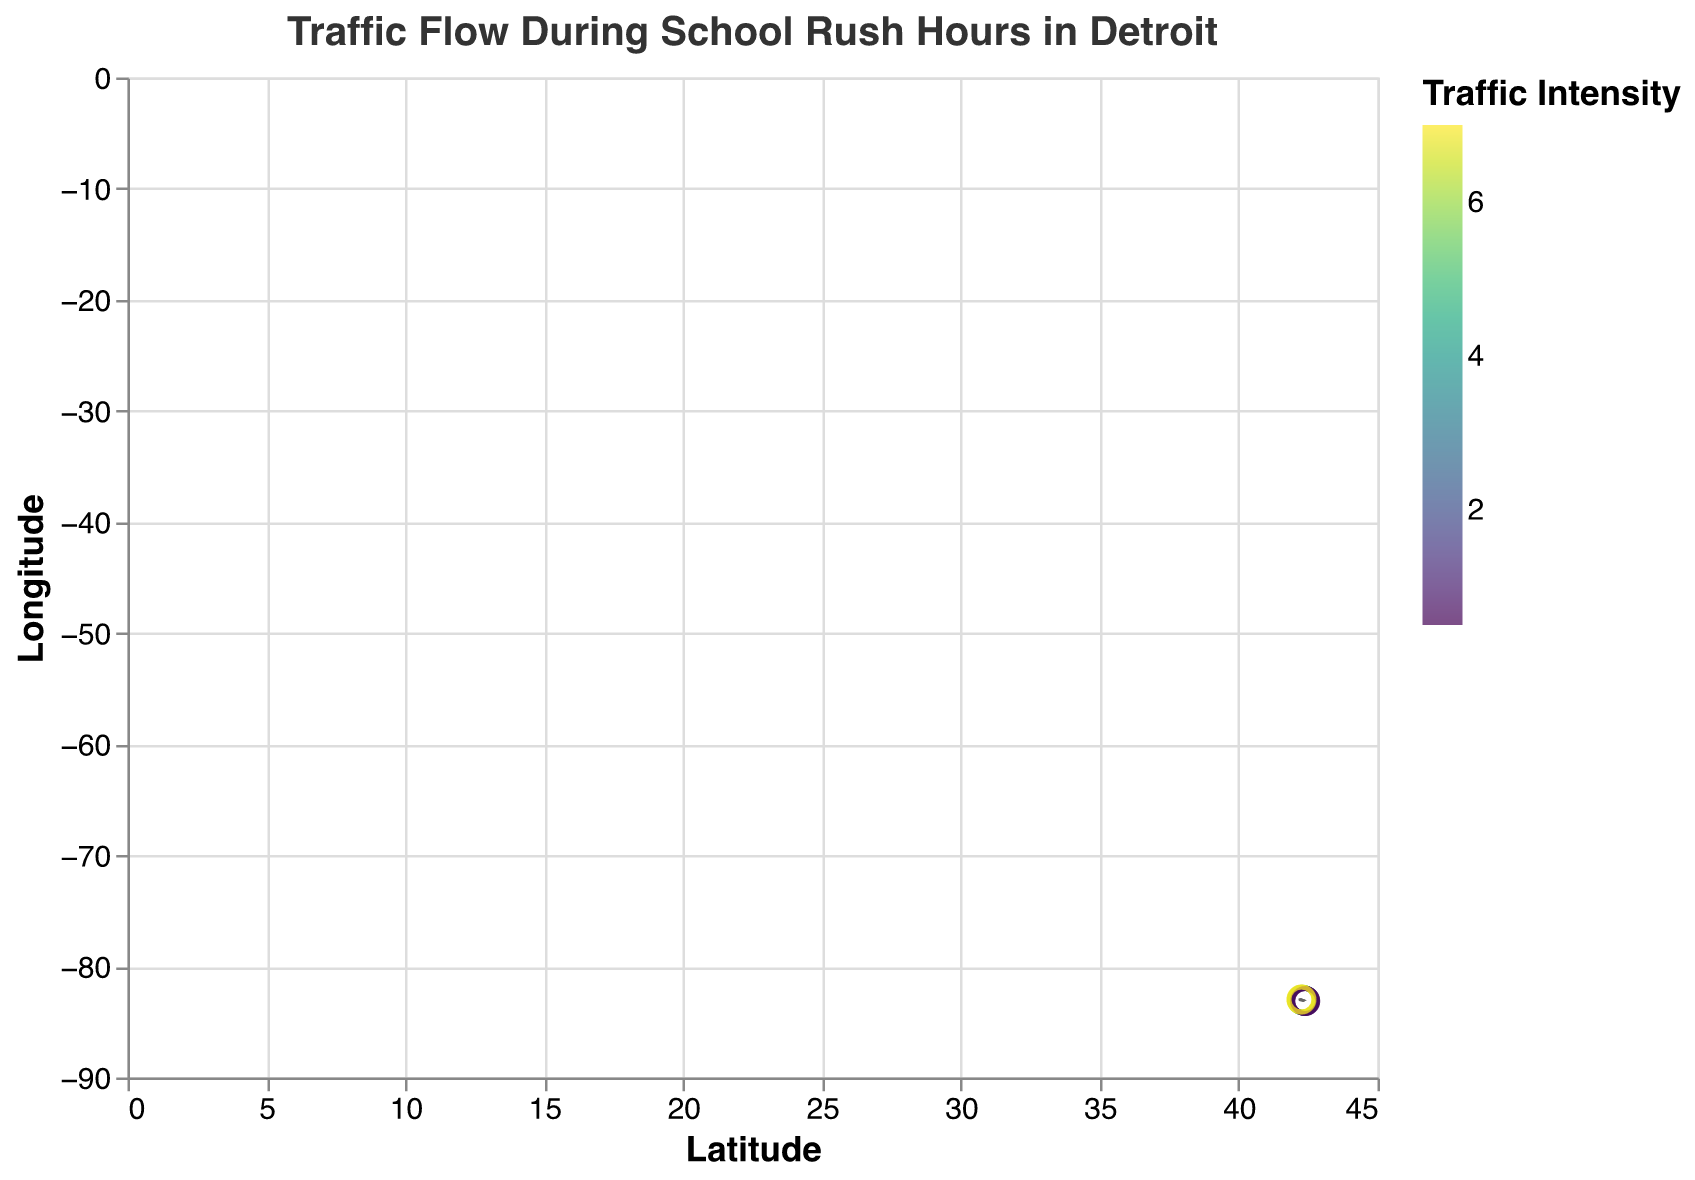What is the title of the figure? The title of the figure is prominently displayed at the top. It reads "Traffic Flow During School Rush Hours in Detroit".
Answer: Traffic Flow During School Rush Hours in Detroit How many data points are represented in the plot? There are a total of 15 points represented in the plot, each with a specific latitude and longitude configuration.
Answer: 15 Which point has the highest traffic intensity and what is its value? The color intensity of the points indicates traffic flow. The point at (42.26, -82.98) has the deepest color, corresponding to the highest traffic intensity value of 7.0.
Answer: 7.0 Which two points have the lowest traffic intensity? By observing the color scale, the points at (42.39, -83.11) and (42.40, -83.12) have much lighter colors, indicating the lowest traffic intensity values of 1.0 and 0.5, respectively.
Answer: 1.0 and 0.5 What is the range of longitude values covered in the plot? Longitude values range from the smallest to the highest. The smallest longitude is -83.12 and the highest is -82.98.
Answer: -83.12 to -82.98 What is the direction and magnitude of the vector at (42.30, -83.02)? For the point at (42.30, -83.02), the vector has components u = -1.1 and v = -0.1. The direction can be inferred as southwest, and the magnitude is 5.0.
Answer: southwest, 5.0 Are there more points with a traffic intensity greater than or less than 4.0? By counting the points on the plot, there are 7 points with traffic intensity greater than 4.0 and 8 points with less than 4.0.
Answer: less than 4.0 Which point shows the strongest directional traffic flow and in what direction? The strongest directional flow is indicated by the longest vector. The point at (42.26, -82.98) with vector components u = -1.5 and v = -0.5 shows the strongest flow heading southwest.
Answer: (42.26, -82.98), southwest Which points show vectors moving predominantly north? Vectors moving predominantly north have positive v components. Points at (42.33, -83.05), (42.34, -83.06), (42.35, -83.07), (42.36, -83.08), (42.37, -83.09), (42.38, -83.10), (42.39, -83.11), and (42.40, -83.12) show this behavior.
Answer: (42.33, -83.05), (42.34, -83.06), (42.35, -83.07), (42.36, -83.08), (42.37, -83.09), (42.38, -83.10), (42.39, -83.11), (42.40, -83.12) 